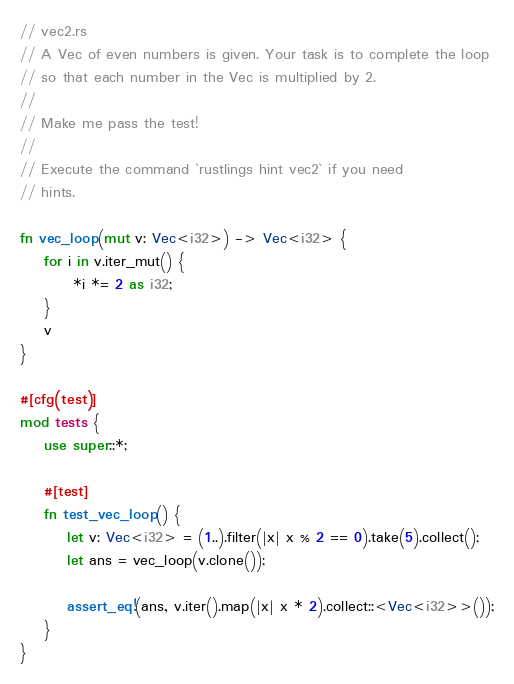Convert code to text. <code><loc_0><loc_0><loc_500><loc_500><_Rust_>// vec2.rs
// A Vec of even numbers is given. Your task is to complete the loop
// so that each number in the Vec is multiplied by 2.
//
// Make me pass the test!
//
// Execute the command `rustlings hint vec2` if you need
// hints.

fn vec_loop(mut v: Vec<i32>) -> Vec<i32> {
    for i in v.iter_mut() {
         *i *= 2 as i32;
    }
    v
}

#[cfg(test)]
mod tests {
    use super::*;

    #[test]
    fn test_vec_loop() {
        let v: Vec<i32> = (1..).filter(|x| x % 2 == 0).take(5).collect();
        let ans = vec_loop(v.clone());

        assert_eq!(ans, v.iter().map(|x| x * 2).collect::<Vec<i32>>());
    }
}
</code> 